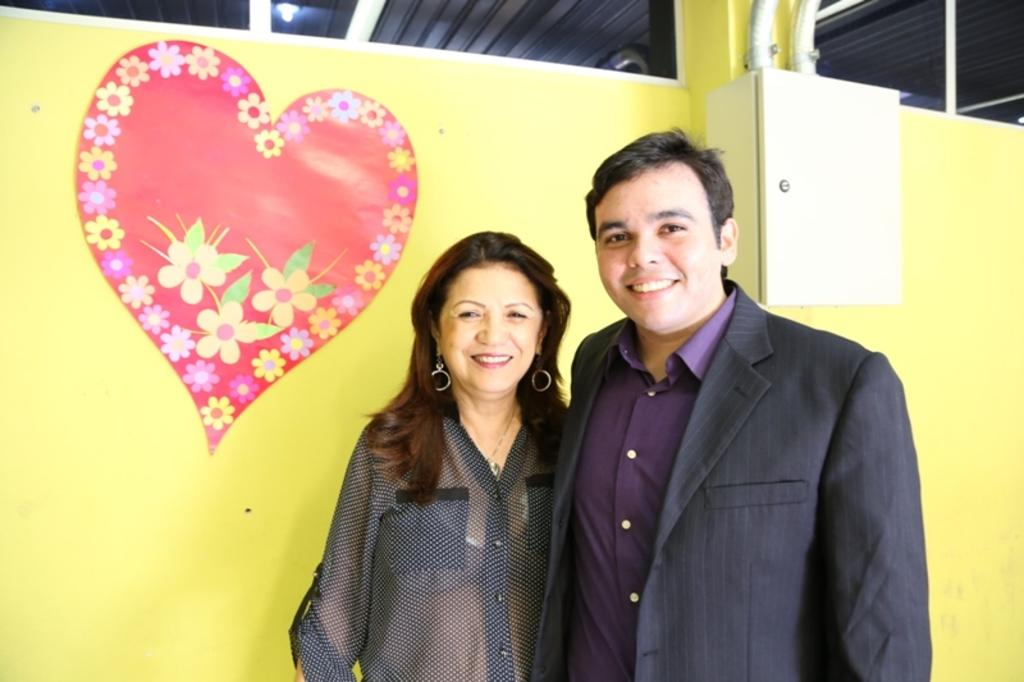How many people are in the image? There are two people in the image, a man and a woman. What are the man and woman doing in the image? Both the man and woman are standing and smiling. What color is the wall in the background of the image? The wall in the background of the image is yellow. What can be seen on the yellow wall? There is a poster on the yellow wall. How far is the lake from the man and woman in the image? There is no lake present in the image, so it is not possible to determine the distance to a lake. 